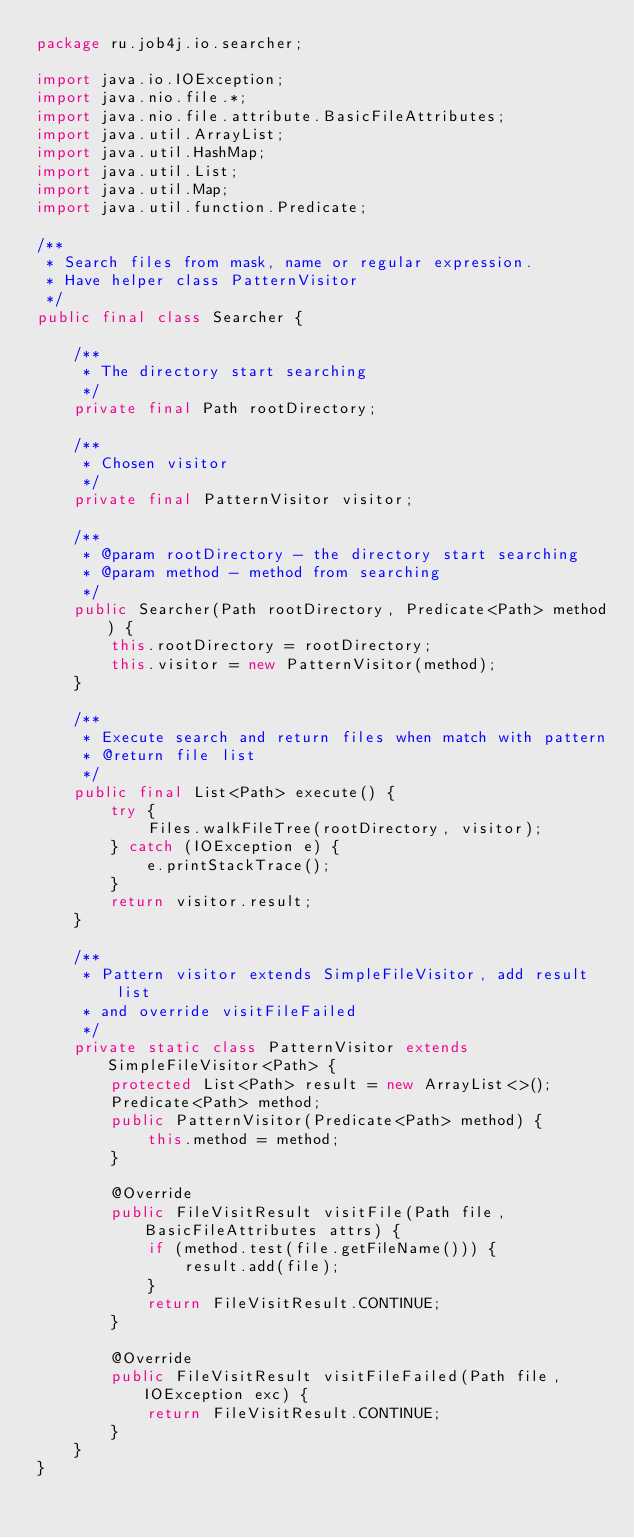Convert code to text. <code><loc_0><loc_0><loc_500><loc_500><_Java_>package ru.job4j.io.searcher;

import java.io.IOException;
import java.nio.file.*;
import java.nio.file.attribute.BasicFileAttributes;
import java.util.ArrayList;
import java.util.HashMap;
import java.util.List;
import java.util.Map;
import java.util.function.Predicate;

/**
 * Search files from mask, name or regular expression.
 * Have helper class PatternVisitor
 */
public final class Searcher {

    /**
     * The directory start searching
     */
    private final Path rootDirectory;

    /**
     * Chosen visitor
     */
    private final PatternVisitor visitor;

    /**
     * @param rootDirectory - the directory start searching
     * @param method - method from searching
     */
    public Searcher(Path rootDirectory, Predicate<Path> method) {
        this.rootDirectory = rootDirectory;
        this.visitor = new PatternVisitor(method);
    }

    /**
     * Execute search and return files when match with pattern
     * @return file list
     */
    public final List<Path> execute() {
        try {
            Files.walkFileTree(rootDirectory, visitor);
        } catch (IOException e) {
            e.printStackTrace();
        }
        return visitor.result;
    }

    /**
     * Pattern visitor extends SimpleFileVisitor, add result list
     * and override visitFileFailed
     */
    private static class PatternVisitor extends SimpleFileVisitor<Path> {
        protected List<Path> result = new ArrayList<>();
        Predicate<Path> method;
        public PatternVisitor(Predicate<Path> method) {
            this.method = method;
        }

        @Override
        public FileVisitResult visitFile(Path file, BasicFileAttributes attrs) {
            if (method.test(file.getFileName())) {
                result.add(file);
            }
            return FileVisitResult.CONTINUE;
        }

        @Override
        public FileVisitResult visitFileFailed(Path file, IOException exc) {
            return FileVisitResult.CONTINUE;
        }
    }
}
</code> 